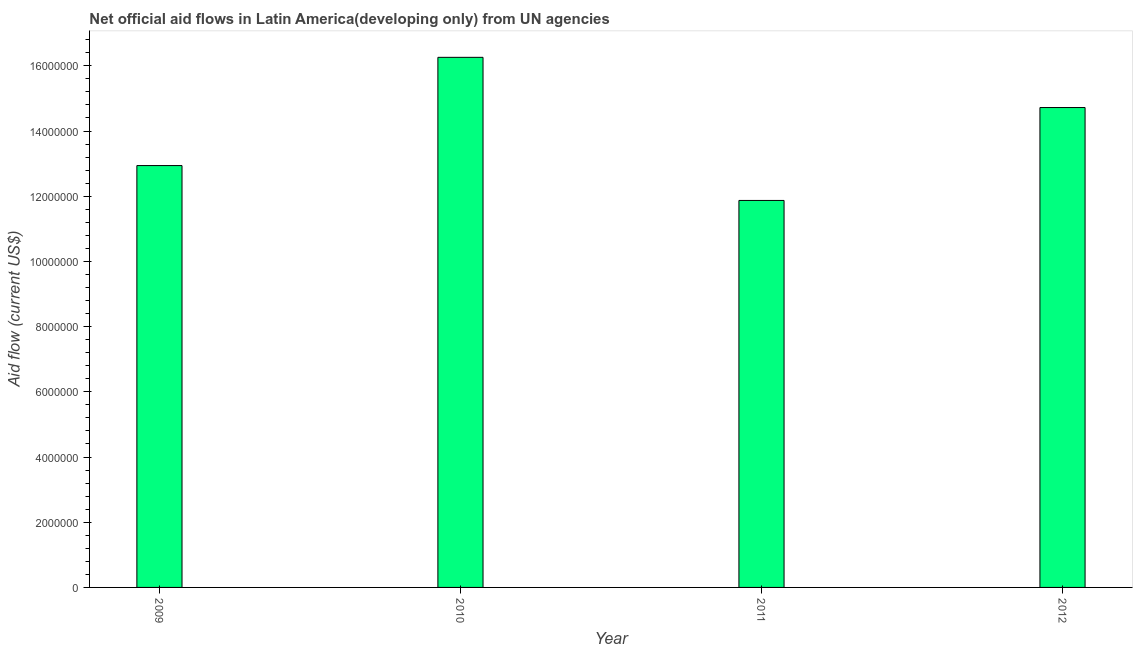Does the graph contain any zero values?
Your answer should be very brief. No. What is the title of the graph?
Keep it short and to the point. Net official aid flows in Latin America(developing only) from UN agencies. What is the net official flows from un agencies in 2011?
Make the answer very short. 1.19e+07. Across all years, what is the maximum net official flows from un agencies?
Give a very brief answer. 1.63e+07. Across all years, what is the minimum net official flows from un agencies?
Ensure brevity in your answer.  1.19e+07. In which year was the net official flows from un agencies minimum?
Offer a terse response. 2011. What is the sum of the net official flows from un agencies?
Provide a short and direct response. 5.58e+07. What is the difference between the net official flows from un agencies in 2010 and 2012?
Provide a short and direct response. 1.54e+06. What is the average net official flows from un agencies per year?
Make the answer very short. 1.39e+07. What is the median net official flows from un agencies?
Your response must be concise. 1.38e+07. Do a majority of the years between 2011 and 2010 (inclusive) have net official flows from un agencies greater than 16400000 US$?
Your response must be concise. No. What is the ratio of the net official flows from un agencies in 2009 to that in 2011?
Give a very brief answer. 1.09. Is the net official flows from un agencies in 2009 less than that in 2011?
Make the answer very short. No. Is the difference between the net official flows from un agencies in 2009 and 2011 greater than the difference between any two years?
Make the answer very short. No. What is the difference between the highest and the second highest net official flows from un agencies?
Your response must be concise. 1.54e+06. What is the difference between the highest and the lowest net official flows from un agencies?
Offer a very short reply. 4.39e+06. Are all the bars in the graph horizontal?
Give a very brief answer. No. How many years are there in the graph?
Provide a succinct answer. 4. What is the Aid flow (current US$) of 2009?
Your answer should be compact. 1.29e+07. What is the Aid flow (current US$) of 2010?
Provide a short and direct response. 1.63e+07. What is the Aid flow (current US$) of 2011?
Your response must be concise. 1.19e+07. What is the Aid flow (current US$) in 2012?
Your answer should be very brief. 1.47e+07. What is the difference between the Aid flow (current US$) in 2009 and 2010?
Keep it short and to the point. -3.32e+06. What is the difference between the Aid flow (current US$) in 2009 and 2011?
Give a very brief answer. 1.07e+06. What is the difference between the Aid flow (current US$) in 2009 and 2012?
Keep it short and to the point. -1.78e+06. What is the difference between the Aid flow (current US$) in 2010 and 2011?
Provide a short and direct response. 4.39e+06. What is the difference between the Aid flow (current US$) in 2010 and 2012?
Provide a short and direct response. 1.54e+06. What is the difference between the Aid flow (current US$) in 2011 and 2012?
Provide a succinct answer. -2.85e+06. What is the ratio of the Aid flow (current US$) in 2009 to that in 2010?
Ensure brevity in your answer.  0.8. What is the ratio of the Aid flow (current US$) in 2009 to that in 2011?
Ensure brevity in your answer.  1.09. What is the ratio of the Aid flow (current US$) in 2009 to that in 2012?
Make the answer very short. 0.88. What is the ratio of the Aid flow (current US$) in 2010 to that in 2011?
Offer a very short reply. 1.37. What is the ratio of the Aid flow (current US$) in 2010 to that in 2012?
Ensure brevity in your answer.  1.1. What is the ratio of the Aid flow (current US$) in 2011 to that in 2012?
Your answer should be compact. 0.81. 